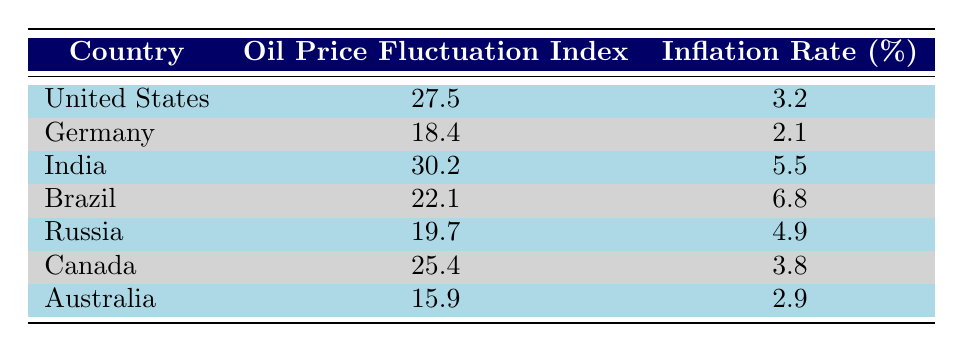What is the oil price fluctuation index for Canada? Canada has an oil price fluctuation index listed in the table, which is 25.4. This information can be found directly in the corresponding row for Canada under the "Oil Price Fluctuation Index" column.
Answer: 25.4 What is the inflation rate for Germany? The inflation rate for Germany can be found in the table under the "Inflation Rate (%)" column. Germany's corresponding inflation rate is 2.1, as indicated in its row.
Answer: 2.1 Which country has the highest inflation rate? To determine the highest inflation rate, all the inflation rates listed in the table must be compared. India has an inflation rate of 5.5, which is higher than all other countries listed (Germany 2.1, Brazil 6.8, etc.). However, compared to Brazil's 6.8, it is incorrect, thus Brazil has the highest inflation rate.
Answer: Brazil Is the oil price fluctuation index for Australia greater than that of Germany? The oil price fluctuation index for Australia is 15.9, while for Germany it is 18.4. By comparing the two values, it is clear that 15.9 is not greater than 18.4. Therefore, the answer is no.
Answer: No What is the average oil price fluctuation index for the listed countries? The oil price fluctuation indices for the countries are: 27.5, 18.4, 30.2, 22.1, 19.7, 25.4, and 15.9. The total of these figures is 27.5 + 18.4 + 30.2 + 22.1 + 19.7 + 25.4 + 15.9 = 159.2. There are 7 countries, so the average is 159.2 / 7 = 22.74.
Answer: 22.74 Is India's inflation rate higher than both Canada and Germany? To answer this, we check India’s inflation rate of 5.5 against Canada’s 3.8 and Germany’s 2.1. Since 5.5 is indeed greater than both 3.8 and 2.1, the answer is yes.
Answer: Yes What is the difference between the highest and lowest inflation rates in the table? The highest inflation rate from the table is 6.8 (Brazil), and the lowest is 2.1 (Germany). The difference can be calculated as 6.8 - 2.1, which equals 4.7.
Answer: 4.7 Which country has an oil price fluctuation index of 19.7? The table shows that Russia has an oil price fluctuation index of 19.7, as indicated in its corresponding row.
Answer: Russia 